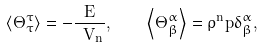<formula> <loc_0><loc_0><loc_500><loc_500>\left \langle \Theta ^ { \tau } _ { \tau } \right \rangle = - \frac { E } { \ V _ { n } } , \quad \left \langle \Theta ^ { \alpha } _ { \beta } \right \rangle = \rho ^ { n } p \delta ^ { \alpha } _ { \beta } ,</formula> 